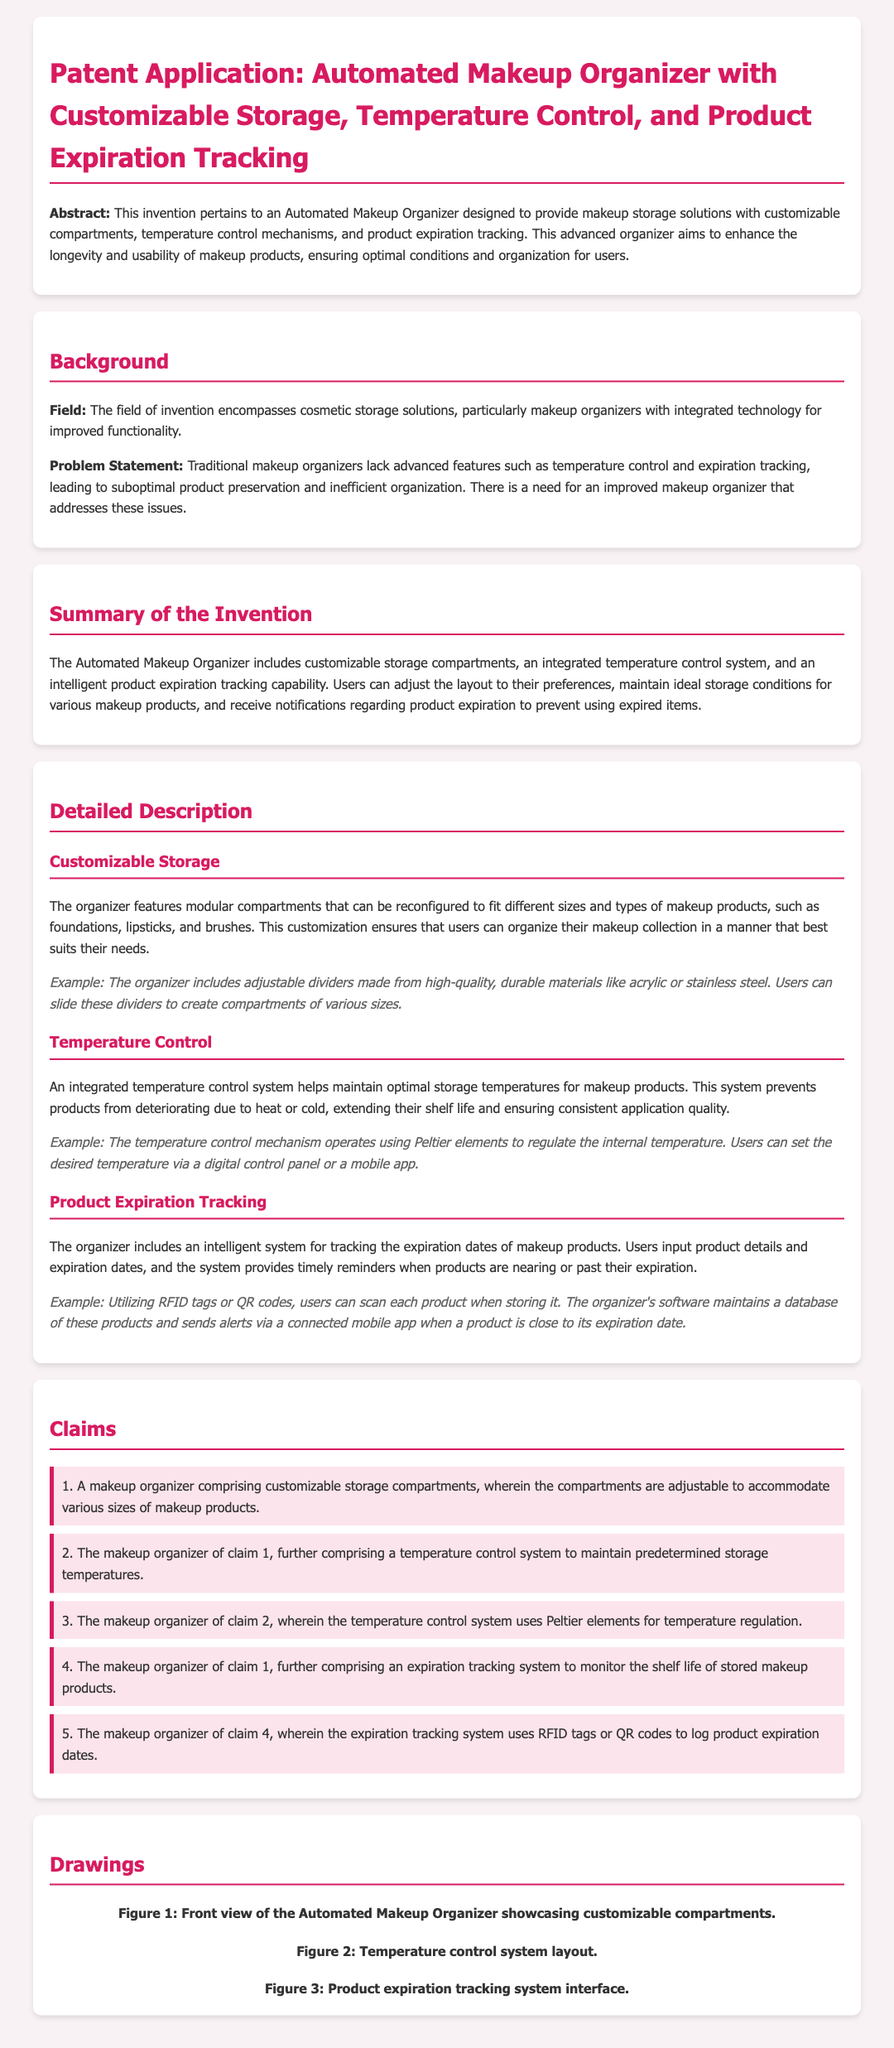What is the title of the patent application? The title is listed at the beginning of the document, providing the specific subject of the invention.
Answer: Automated Makeup Organizer with Customizable Storage, Temperature Control, and Product Expiration Tracking What are the main features of the Automated Makeup Organizer? The abstract summarizes the key features provided in the document, highlighting the technologies used.
Answer: Customizable compartments, temperature control, product expiration tracking Who solves the problem stated in the background? The document mentions an invention that addresses the identified issues in traditional makeup organizers.
Answer: The Automated Makeup Organizer What mechanism does the temperature control system use? The detailed description specifies the technology utilized for temperature regulation within the organizer.
Answer: Peltier elements What is the purpose of the product expiration tracking system? The detailed description outlines the function of this system in ensuring product safety and usability.
Answer: To monitor the shelf life of stored makeup products What user input is required for expiration tracking? The explanation provided in the document indicates the interaction needed from users for product monitoring.
Answer: Product details and expiration dates How many claims are listed in the document? The claims section notes the specific protections sought in the patent, which can be counted for total understanding.
Answer: Five What type of materials are used for adjustable dividers? The example in the document specifies the quality of materials used for customization features.
Answer: Acrylic or stainless steel What does the organizer notify users about? The system's functionality is explained concerning user alerts for safety and usability of makeup products.
Answer: Product expiration 